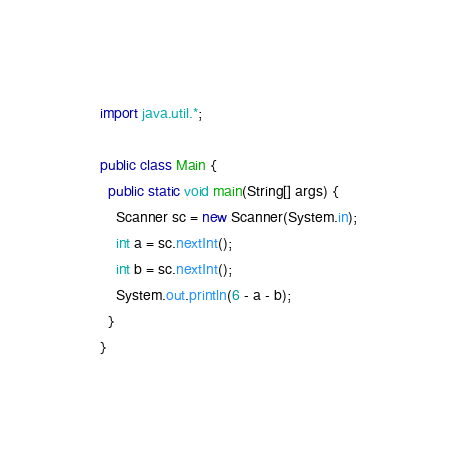Convert code to text. <code><loc_0><loc_0><loc_500><loc_500><_Java_>import java.util.*;

public class Main {
  public static void main(String[] args) {
    Scanner sc = new Scanner(System.in);
    int a = sc.nextInt();
    int b = sc.nextInt();
    System.out.println(6 - a - b);
  }
}</code> 